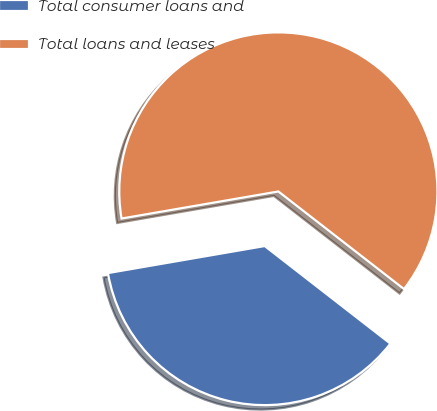Convert chart. <chart><loc_0><loc_0><loc_500><loc_500><pie_chart><fcel>Total consumer loans and<fcel>Total loans and leases<nl><fcel>36.77%<fcel>63.23%<nl></chart> 